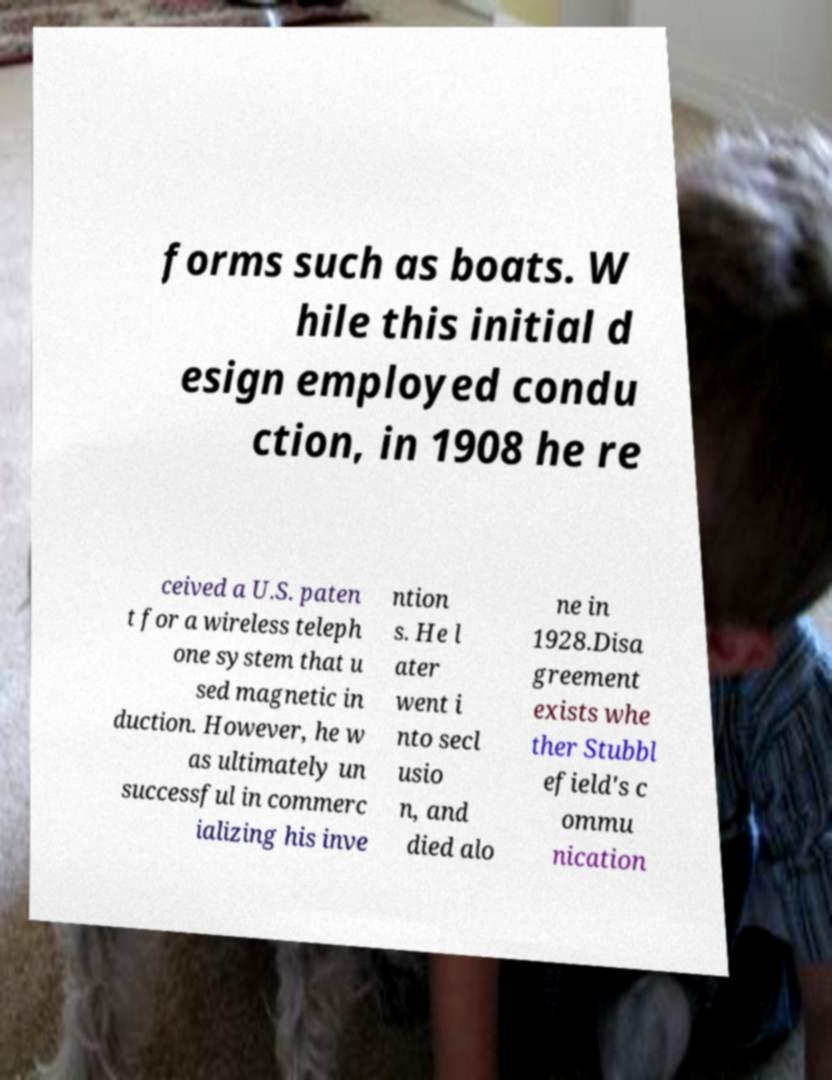Could you assist in decoding the text presented in this image and type it out clearly? forms such as boats. W hile this initial d esign employed condu ction, in 1908 he re ceived a U.S. paten t for a wireless teleph one system that u sed magnetic in duction. However, he w as ultimately un successful in commerc ializing his inve ntion s. He l ater went i nto secl usio n, and died alo ne in 1928.Disa greement exists whe ther Stubbl efield's c ommu nication 